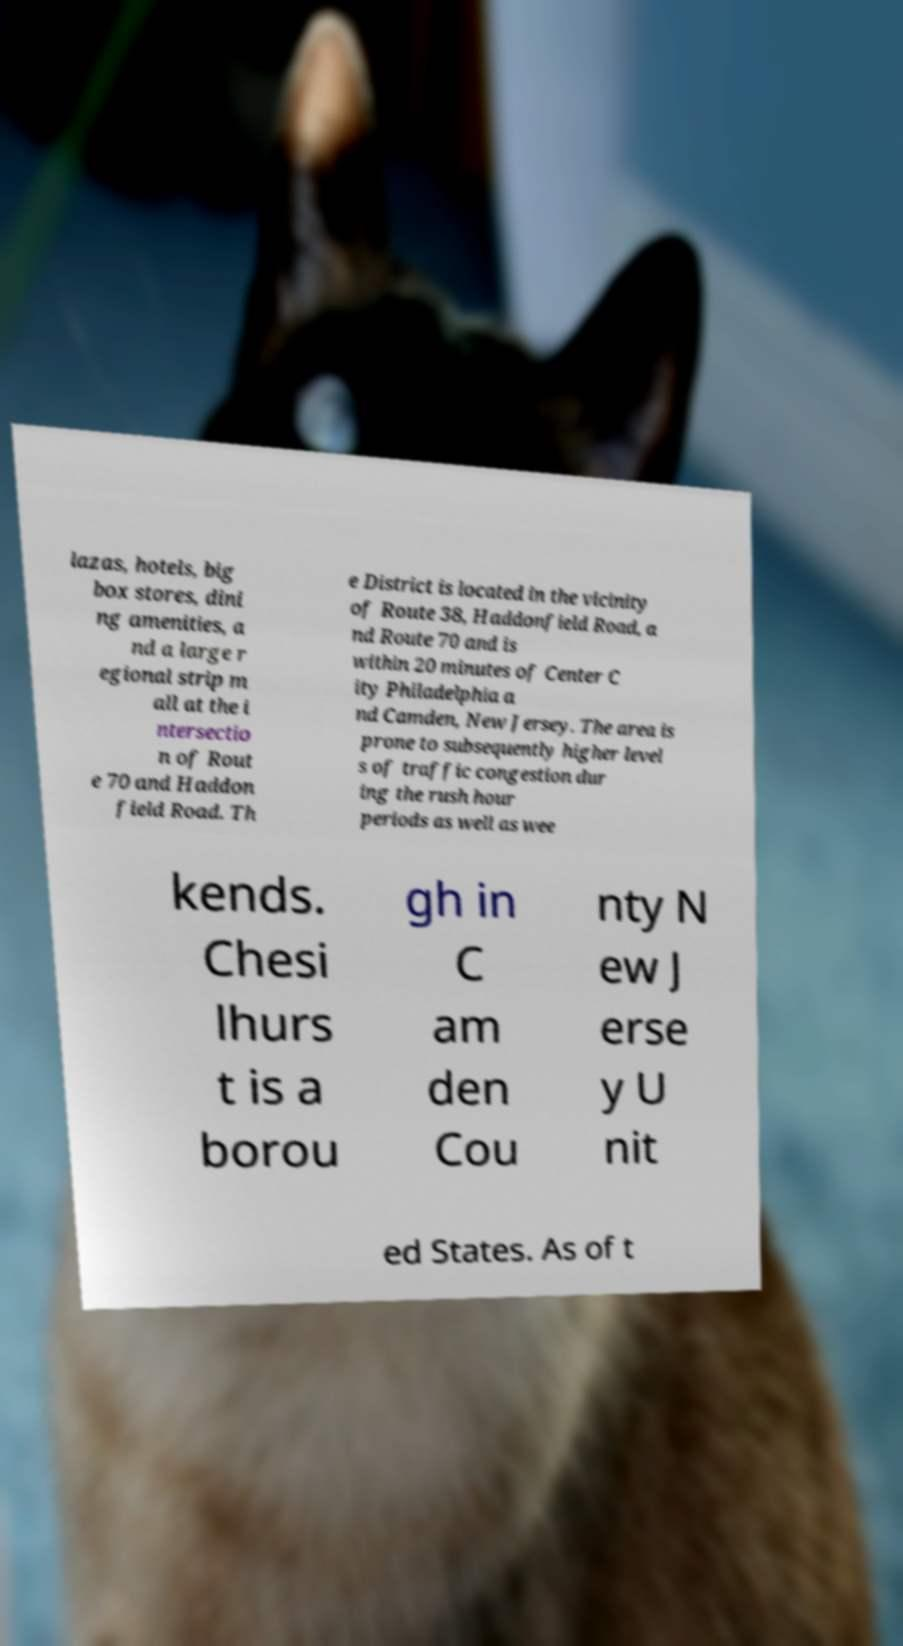There's text embedded in this image that I need extracted. Can you transcribe it verbatim? lazas, hotels, big box stores, dini ng amenities, a nd a large r egional strip m all at the i ntersectio n of Rout e 70 and Haddon field Road. Th e District is located in the vicinity of Route 38, Haddonfield Road, a nd Route 70 and is within 20 minutes of Center C ity Philadelphia a nd Camden, New Jersey. The area is prone to subsequently higher level s of traffic congestion dur ing the rush hour periods as well as wee kends. Chesi lhurs t is a borou gh in C am den Cou nty N ew J erse y U nit ed States. As of t 